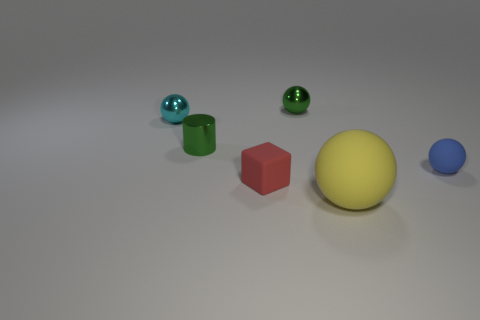If this image was from a child's educational material, what lesson might it be teaching? This image is likely designed to teach children about shapes and colors. It offers a visual aid to identify and differentiate between various geometric figures and to associate them with their corresponding names and colors. It might also be used to explain counting, as the children could be asked to count the number of objects or sort them based on shape or color. 